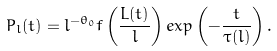<formula> <loc_0><loc_0><loc_500><loc_500>P _ { l } ( t ) = l ^ { - \theta _ { 0 } } f \left ( \frac { L ( t ) } { l } \right ) e x p \left ( - \frac { t } { \tau ( l ) } \right ) .</formula> 